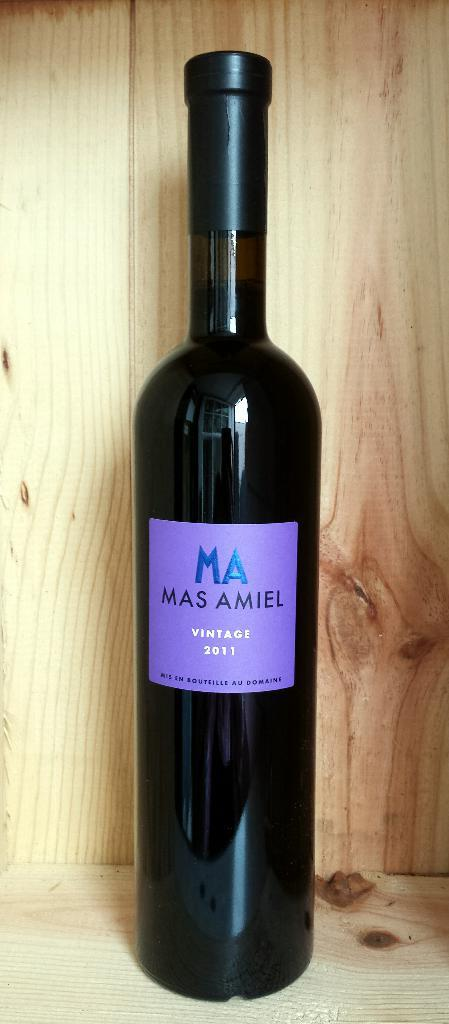Provide a one-sentence caption for the provided image. A bottle of red wine with the letters MA on it in blue. 